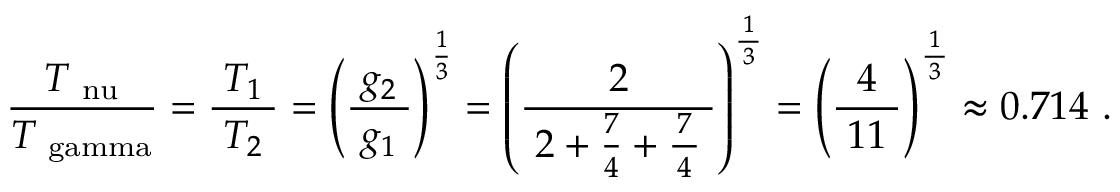Convert formula to latex. <formula><loc_0><loc_0><loc_500><loc_500>{ \frac { \, T _ { \ n u } \, } { T _ { \ g a m m a } } } = { \frac { \, T _ { 1 } \, } { T _ { 2 } } } = \left ( { \frac { \, g _ { 2 } \, } { g _ { 1 } } } \right ) ^ { \frac { 1 } { 3 } } = \left ( { \frac { 2 } { \, 2 + { \frac { 7 } { 4 } } + { \frac { \, 7 \, } { 4 } } \, } } \right ) ^ { \frac { \, 1 \, } { 3 } } = \left ( { \frac { 4 } { \, 1 1 \, } } \right ) ^ { \frac { \, 1 \, } { 3 } } \approx { 0 . 7 1 4 } .</formula> 